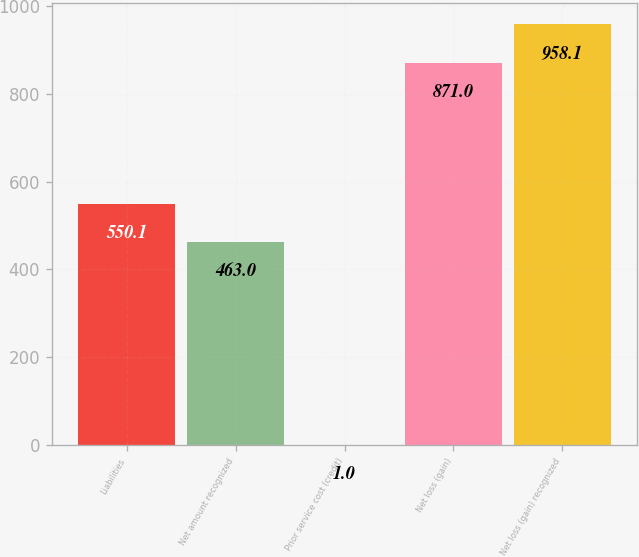Convert chart. <chart><loc_0><loc_0><loc_500><loc_500><bar_chart><fcel>Liabilities<fcel>Net amount recognized<fcel>Prior service cost (credit)<fcel>Net loss (gain)<fcel>Net loss (gain) recognized<nl><fcel>550.1<fcel>463<fcel>1<fcel>871<fcel>958.1<nl></chart> 